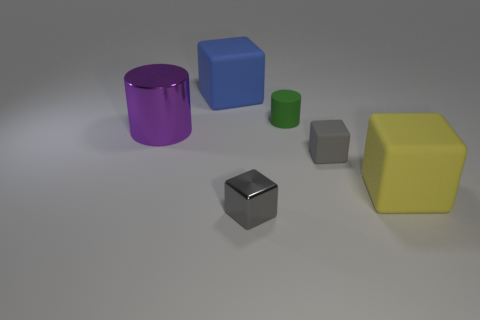What material is the other block that is the same color as the small rubber block?
Provide a succinct answer. Metal. Are there an equal number of cubes in front of the metal block and matte objects that are in front of the gray matte object?
Provide a succinct answer. No. Are there more small green cylinders than tiny cyan things?
Give a very brief answer. Yes. What number of rubber things are green cubes or things?
Your response must be concise. 4. What number of small metal things are the same color as the large metallic cylinder?
Your answer should be compact. 0. What is the small cube that is in front of the large block right of the big matte cube that is to the left of the large yellow thing made of?
Make the answer very short. Metal. What is the color of the rubber cube that is on the left side of the cylinder to the right of the gray metal cube?
Keep it short and to the point. Blue. How many big things are either rubber blocks or blocks?
Make the answer very short. 2. What number of other things are the same material as the tiny green object?
Give a very brief answer. 3. How big is the gray thing that is on the right side of the small cylinder?
Offer a very short reply. Small. 